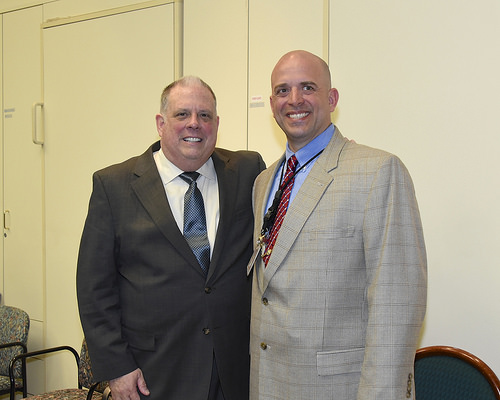<image>
Can you confirm if the man is on the chair? No. The man is not positioned on the chair. They may be near each other, but the man is not supported by or resting on top of the chair. 